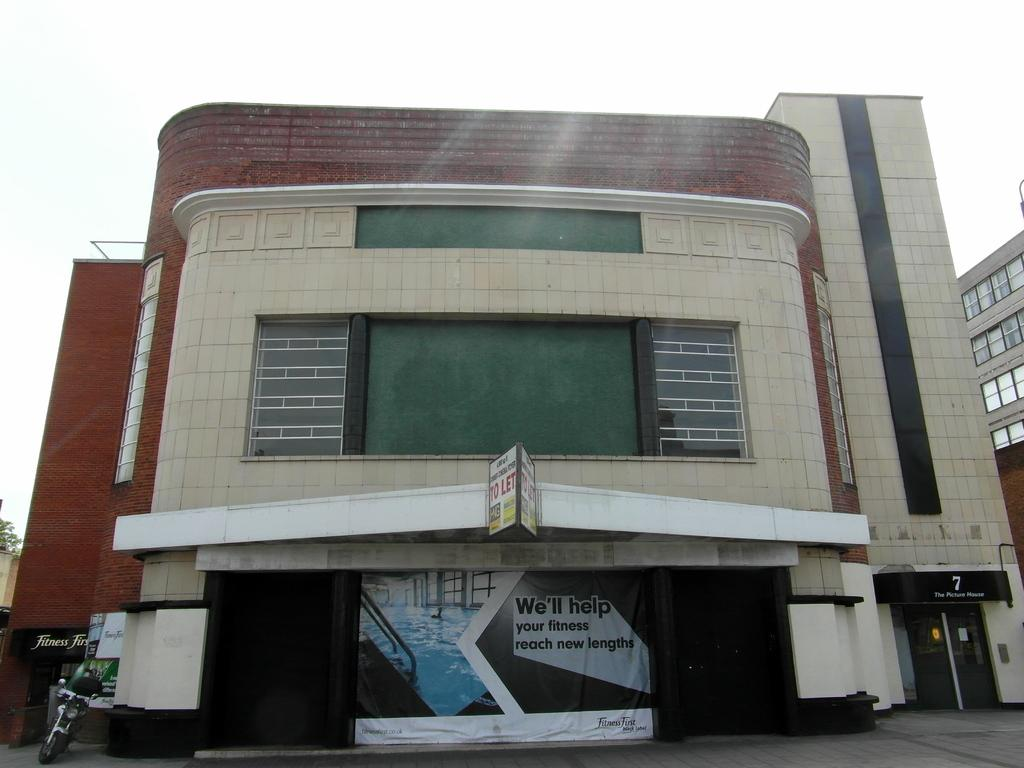What type of structure can be seen in the image? There is a building in the image. What is attached to the building? There is a board and a banner attached to the building. What vehicle is parked on the left side of the image? A motorbike is parked on the left side of the image. What is visible on the right side of the image? There is another building on the right side of the image. What can be seen in the background of the image? The sky is visible in the background of the image. What historical event is being commemorated by the banner in the image? There is no indication of a historical event being commemorated by the banner in the image. How does the toad contribute to the peace in the image? There is no toad present in the image, so it cannot contribute to the peace. 